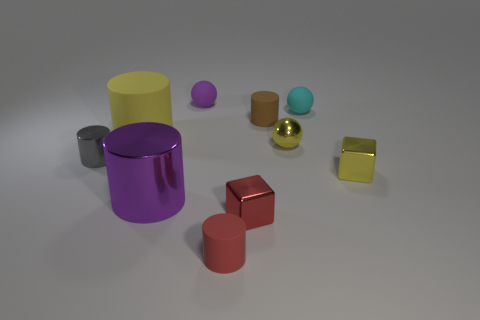Subtract all small cyan balls. How many balls are left? 2 Subtract 1 cylinders. How many cylinders are left? 4 Subtract all purple cylinders. How many cylinders are left? 4 Subtract 0 purple blocks. How many objects are left? 10 Subtract all cubes. How many objects are left? 8 Subtract all gray balls. Subtract all blue blocks. How many balls are left? 3 Subtract all large gray shiny objects. Subtract all big yellow rubber objects. How many objects are left? 9 Add 7 big purple metal cylinders. How many big purple metal cylinders are left? 8 Add 10 tiny green matte spheres. How many tiny green matte spheres exist? 10 